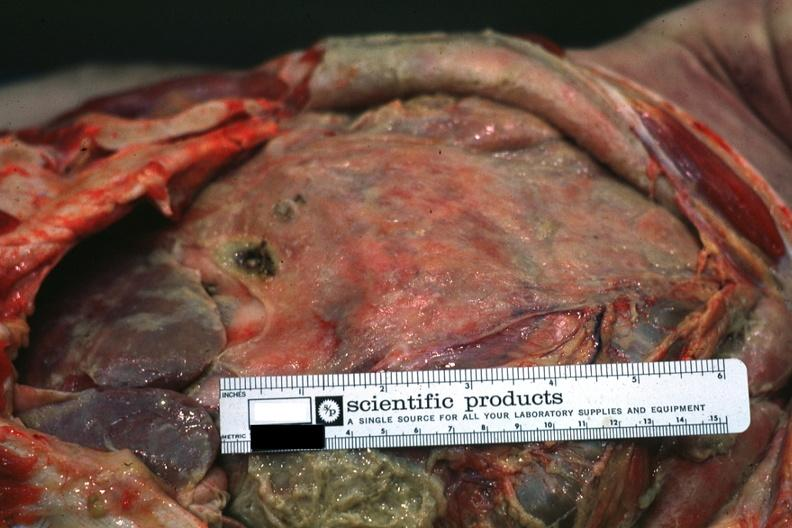what is present?
Answer the question using a single word or phrase. Abdomen 